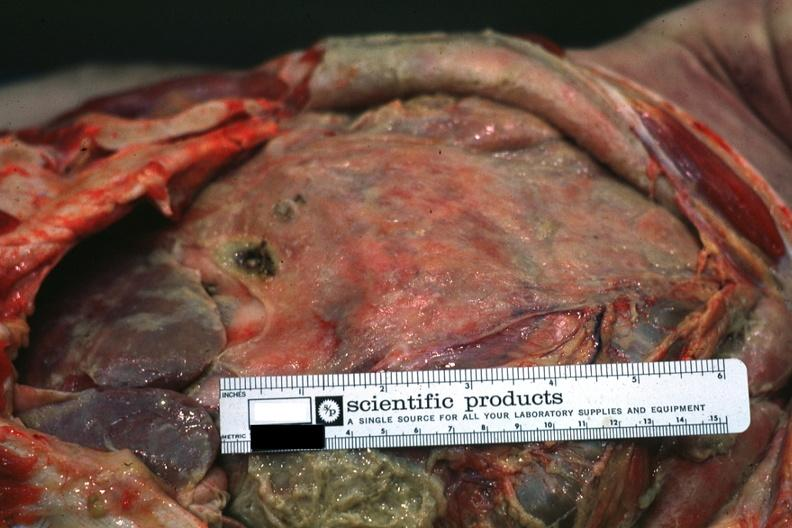what is present?
Answer the question using a single word or phrase. Abdomen 